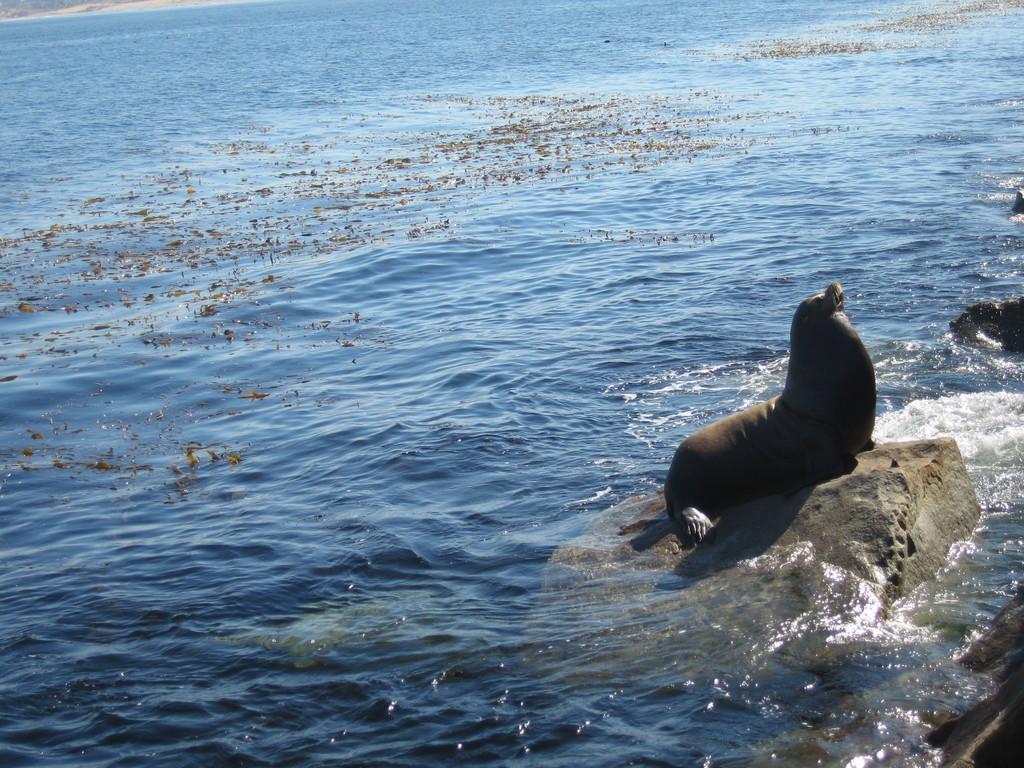In one or two sentences, can you explain what this image depicts? In this image, there is a seal fish on the rock which is in the sea. 